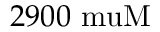<formula> <loc_0><loc_0><loc_500><loc_500>2 9 0 0 \ m u M</formula> 